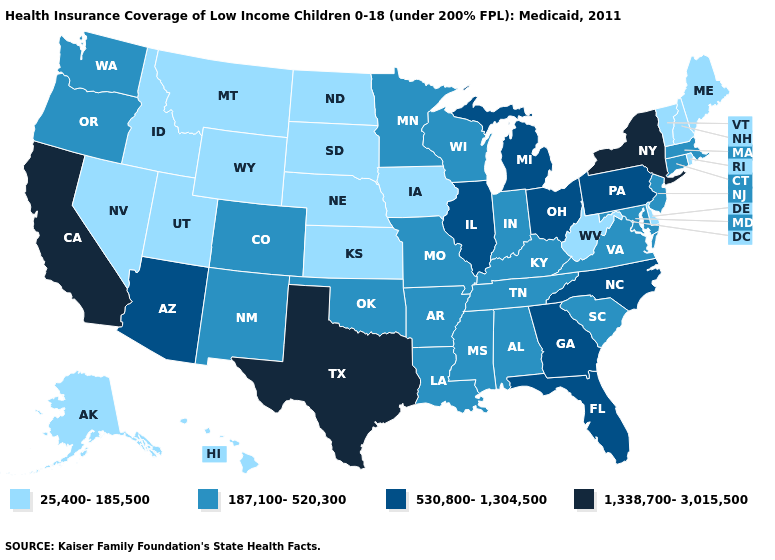Does the first symbol in the legend represent the smallest category?
Write a very short answer. Yes. How many symbols are there in the legend?
Be succinct. 4. Which states have the lowest value in the Northeast?
Write a very short answer. Maine, New Hampshire, Rhode Island, Vermont. What is the highest value in the Northeast ?
Answer briefly. 1,338,700-3,015,500. Does Colorado have the lowest value in the USA?
Answer briefly. No. Does New York have the highest value in the Northeast?
Give a very brief answer. Yes. What is the value of Pennsylvania?
Give a very brief answer. 530,800-1,304,500. Which states hav the highest value in the West?
Concise answer only. California. What is the value of Pennsylvania?
Quick response, please. 530,800-1,304,500. Name the states that have a value in the range 187,100-520,300?
Keep it brief. Alabama, Arkansas, Colorado, Connecticut, Indiana, Kentucky, Louisiana, Maryland, Massachusetts, Minnesota, Mississippi, Missouri, New Jersey, New Mexico, Oklahoma, Oregon, South Carolina, Tennessee, Virginia, Washington, Wisconsin. What is the highest value in states that border Nebraska?
Keep it brief. 187,100-520,300. Name the states that have a value in the range 187,100-520,300?
Answer briefly. Alabama, Arkansas, Colorado, Connecticut, Indiana, Kentucky, Louisiana, Maryland, Massachusetts, Minnesota, Mississippi, Missouri, New Jersey, New Mexico, Oklahoma, Oregon, South Carolina, Tennessee, Virginia, Washington, Wisconsin. What is the value of Vermont?
Give a very brief answer. 25,400-185,500. What is the value of New Jersey?
Be succinct. 187,100-520,300. Name the states that have a value in the range 1,338,700-3,015,500?
Concise answer only. California, New York, Texas. 